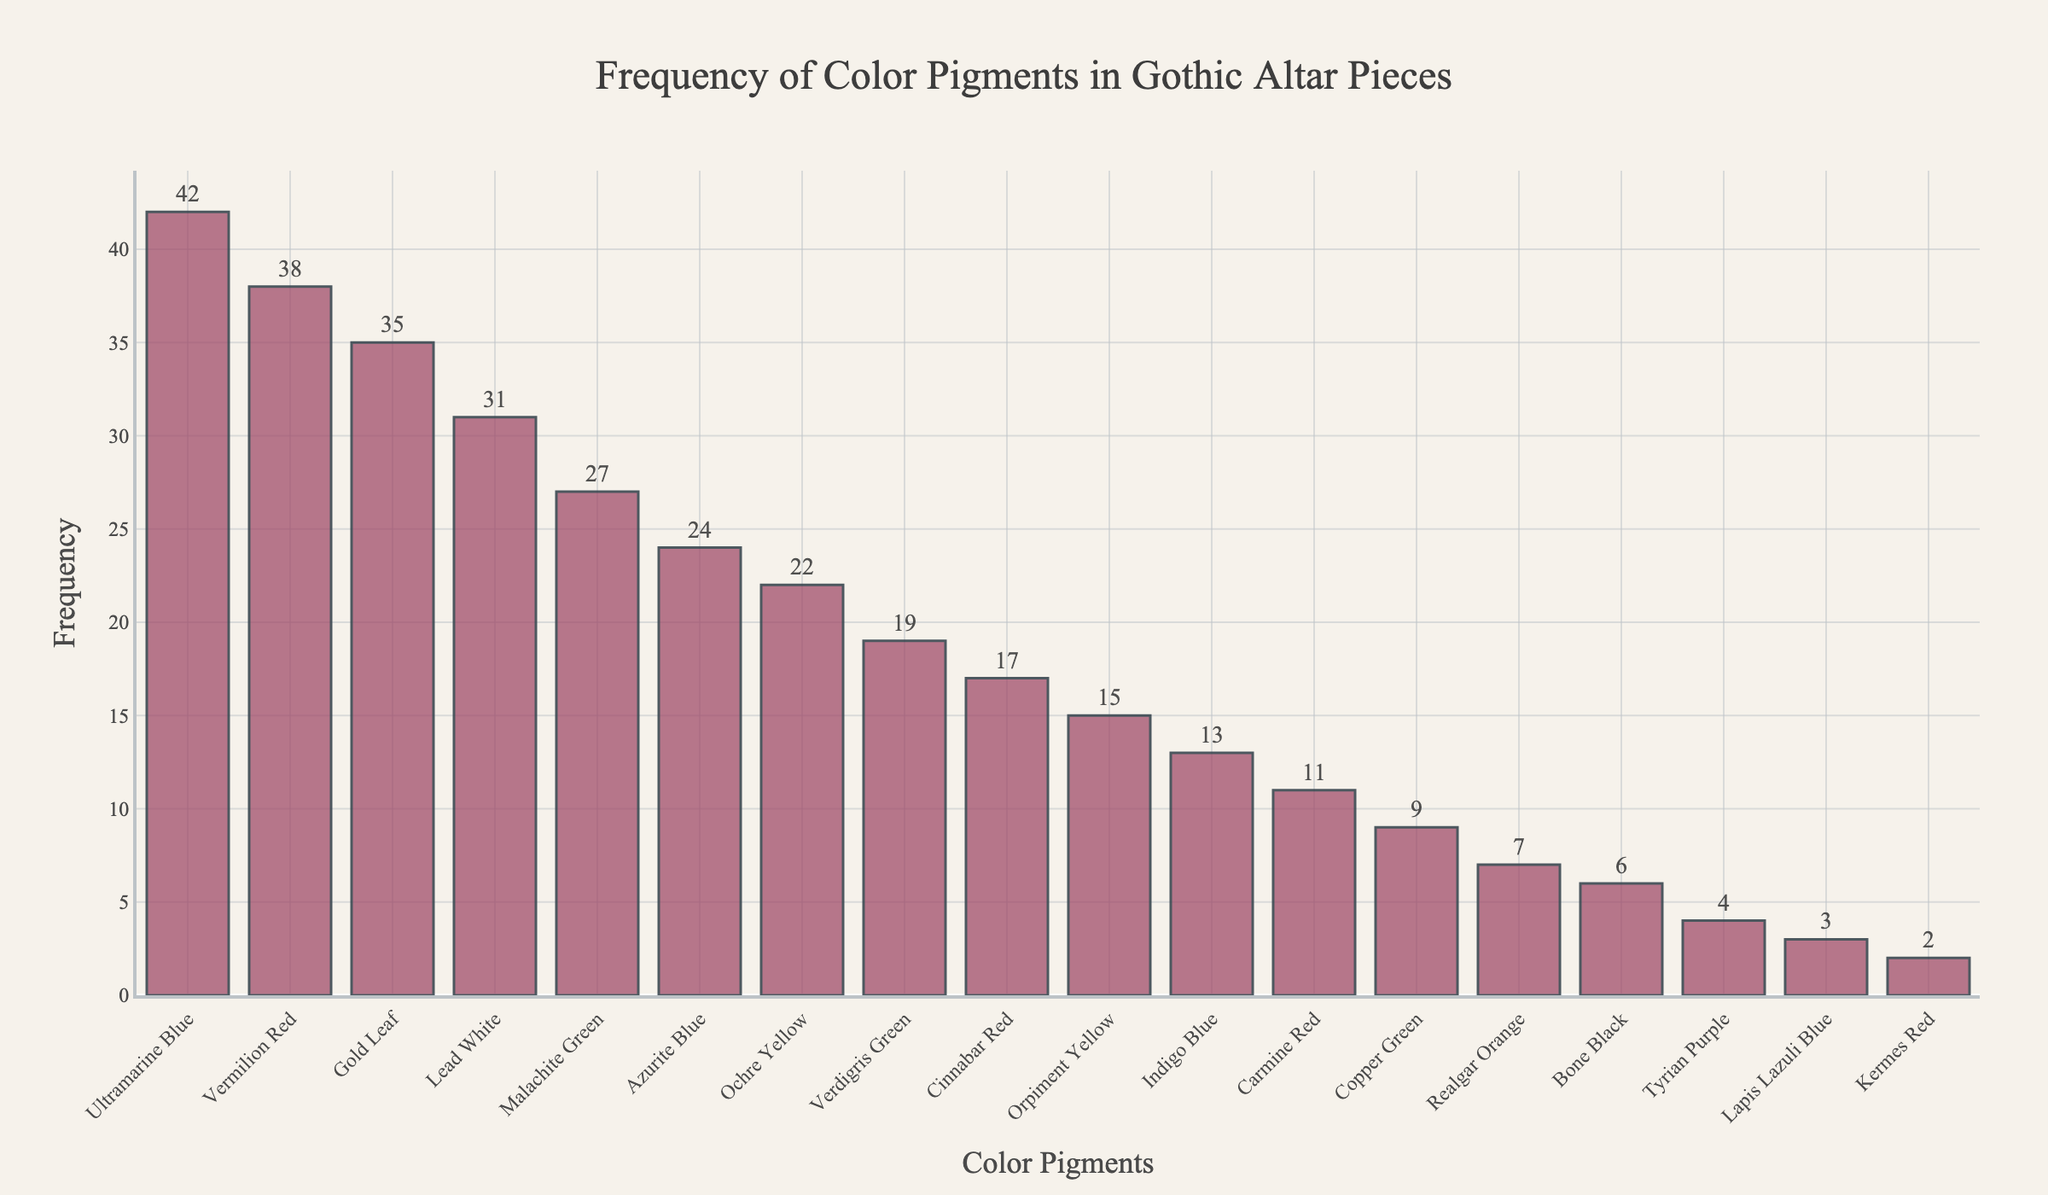Which color pigment appears most frequently in Gothic altar pieces? The bar labeled "Ultramarine Blue" is the tallest among the bars in the chart, indicating it has the highest frequency.
Answer: Ultramarine Blue Which two color pigments have the closest frequency values? By examining the heights of the bars, "Vermilion Red" and "Gold Leaf" have frequencies of 38 and 35 respectively, which are closest among all pairs.
Answer: Vermilion Red and Gold Leaf What is the combined frequency of the three least frequently used color pigments? The bars for "Kermes Red," "Lapis Lazuli Blue," and "Tyrian Purple" have frequencies of 2, 3, and 4 respectively. Adding these together: 2 + 3 + 4 = 9.
Answer: 9 How does the frequency of "Ochre Yellow" compare to "Cinnabar Red"? "Ochre Yellow" has a frequency of 22, which is higher than the frequency of 17 for "Cinnabar Red."
Answer: Ochre Yellow is higher What is the difference in frequency between "Lead White" and "Malachite Green"? "Lead White" has a frequency of 31, while "Malachite Green" has a frequency of 27. The difference is 31 - 27 = 4.
Answer: 4 Which color pigments have a frequency between 10 and 20 inclusive? The bars for "Verdigris Green," "Cinnabar Red," "Orpiment Yellow," "Indigo Blue," and "Carmine Red" fall within this range with frequencies of 19, 17, 15, 13, and 11 respectively.
Answer: Verdigris Green, Cinnabar Red, Orpiment Yellow, Indigo Blue, Carmine Red What is the average frequency of the four most frequently used color pigments? The top four bars are "Ultramarine Blue" (42), "Vermilion Red" (38), "Gold Leaf" (35), and "Lead White" (31). The sum of these frequencies is 42 + 38 + 35 + 31 = 146. Dividing this total by 4 gives 146/4 = 36.5.
Answer: 36.5 Is "Bone Black" used more frequently than "Tyrian Purple"? "Bone Black" has a frequency of 6, whereas "Tyrian Purple" has a frequency of 4, indicating that "Bone Black" is used more frequently.
Answer: Yes, Bone Black is used more frequently Identify the color pigment with the median frequency value. The median is the middle value in the sorted list. Listing the frequencies in ascending order: 2, 3, 4, 6, 7, 9, 11, 13, 15, 17, 19, 22, 24, 27, 31, 35, 38, 42. The median is the average of the 9th and 10th values: (15 + 17) / 2 = 16. There is no pigment with exact frequency 16, so examine the context; Cinnabar Red (17) or Orpiment Yellow (15) would be referenced.
Answer: 16 (Orpiment Yellow + Cinnabar Red) How frequently is "Copper Green" used compared to "Bone Black"? "Copper Green" has a frequency of 9, whereas "Bone Black" has a frequency of 6.
Answer: Copper Green is used more frequently 